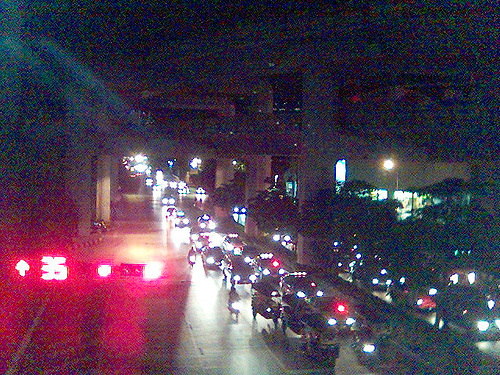Please extract the text content from this image. 35 